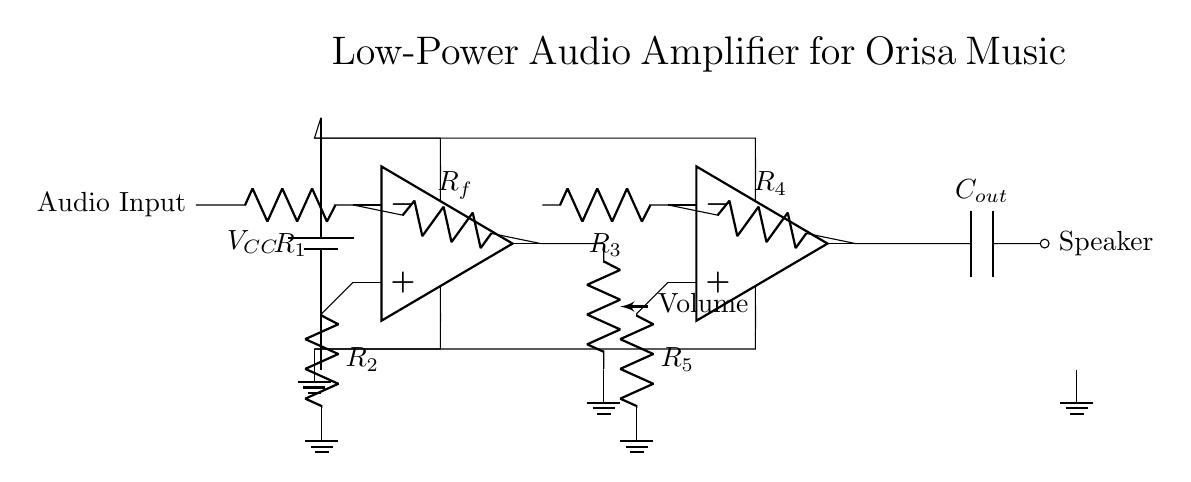What is the power supply voltage for this circuit? The circuit uses a battery (seen at the top) labeled V CC, but the actual voltage value is not specified in the diagram. However, it commonly can be assumed to be 5V for low-power applications.
Answer: 5V What component is used for volume control? The volume control in the circuit is indicated as a potentiometer connected to the output of the first operational amplifier. It adjusts the audio level sent to the next stage.
Answer: Potentiometer How many operational amplifiers are present in this circuit? There are two operational amplifiers clearly marked in the diagram, each performing amplification in different stages of the circuit.
Answer: Two What is the purpose of the capacitor connected to the output? The capacitor labeled as C out blocks any DC component from the output and allows only the AC component (audio signal) to reach the speaker, thereby preventing damage to the speaker.
Answer: To block DC What are the resistors labeled R 1 and R 2 used for? Resistors R 1 and R 2 provide feedback and set gain in the first operational amplifier stage, affecting the overall amplification and stability of the circuit.
Answer: Feedback and gain adjustment What is the total number of resistors used in the entire circuit? Counting all the resistors in the circuit, we have R 1, R f, R 2, R 3, R 4, and R 5, making a total of five resistors.
Answer: Five 